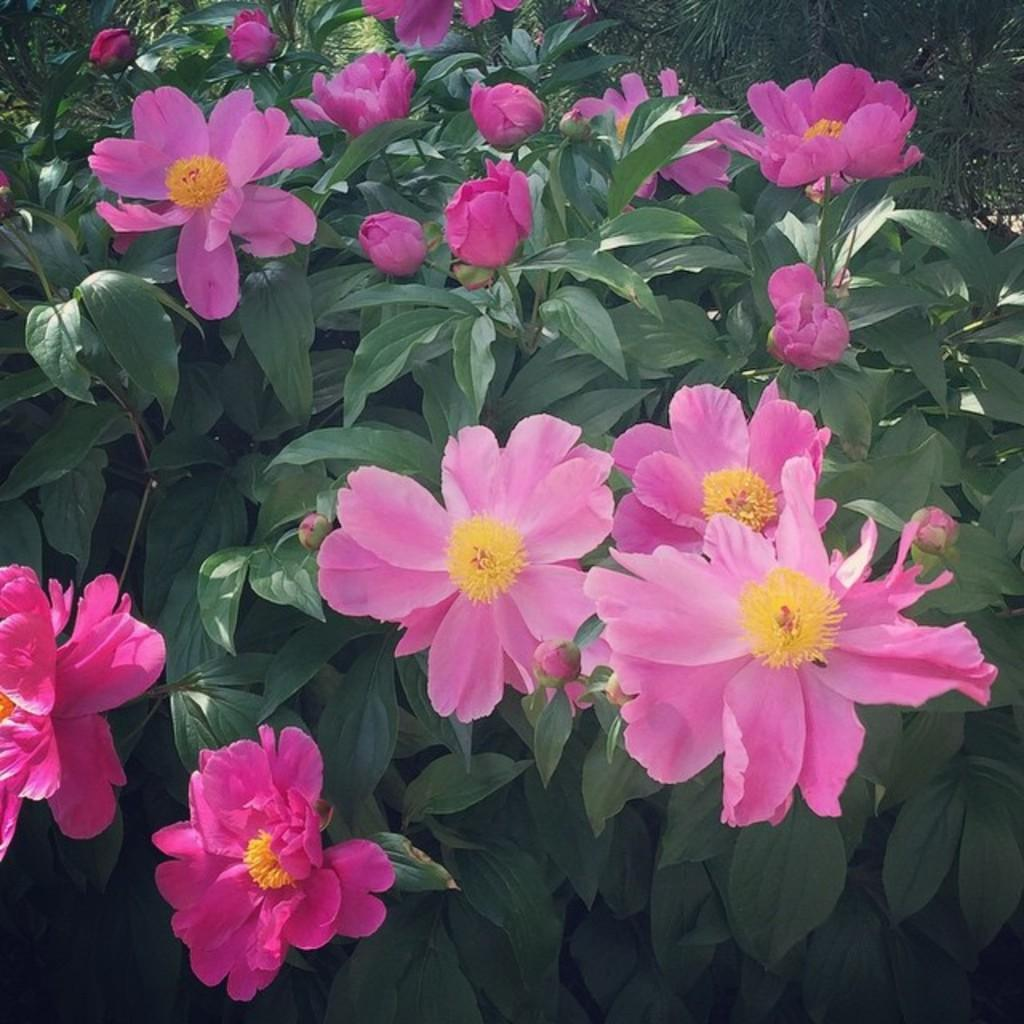What color are the flowers in the image? The flowers in the image are pink. What else can be seen in the background of the image? There are plants in the background of the image. What type of ring is the daughter wearing in the image? There is no daughter or ring present in the image; it only features pink flowers and plants in the background. 